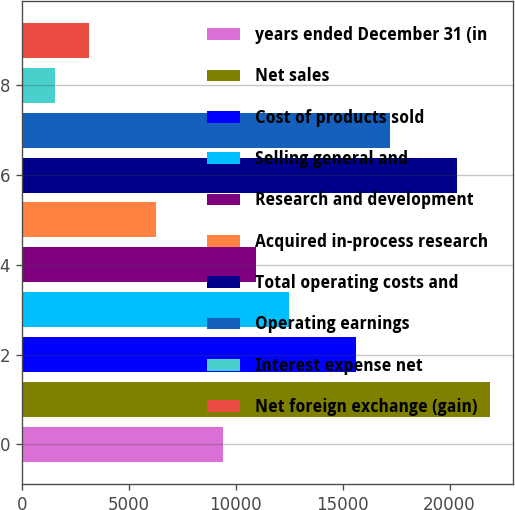<chart> <loc_0><loc_0><loc_500><loc_500><bar_chart><fcel>years ended December 31 (in<fcel>Net sales<fcel>Cost of products sold<fcel>Selling general and<fcel>Research and development<fcel>Acquired in-process research<fcel>Total operating costs and<fcel>Operating earnings<fcel>Interest expense net<fcel>Net foreign exchange (gain)<nl><fcel>9383.89<fcel>21892.2<fcel>15638<fcel>12511<fcel>10947.4<fcel>6256.81<fcel>20328.6<fcel>17201.6<fcel>1566.19<fcel>3129.73<nl></chart> 